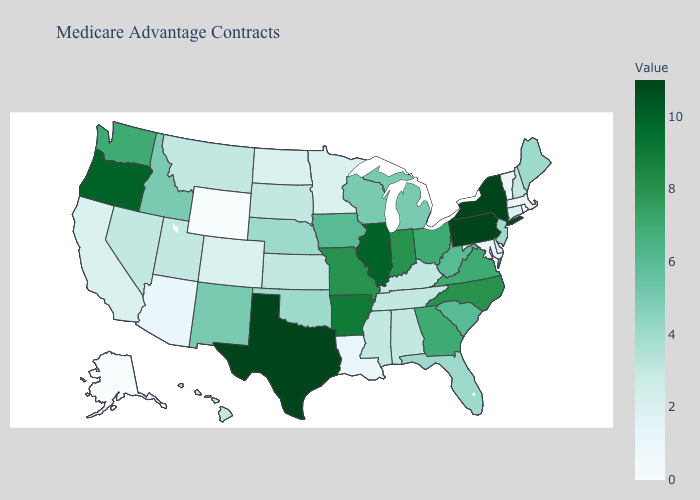Does Maryland have the highest value in the USA?
Be succinct. No. Among the states that border Oklahoma , which have the highest value?
Short answer required. Texas. Does Mississippi have the lowest value in the South?
Answer briefly. No. Does the map have missing data?
Keep it brief. No. Does Kentucky have the highest value in the USA?
Short answer required. No. 